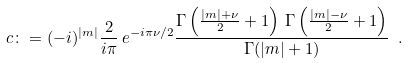Convert formula to latex. <formula><loc_0><loc_0><loc_500><loc_500>c \colon = ( - i ) ^ { | m | } \frac { 2 } { i \pi } \, e ^ { - i \pi \nu / 2 } \frac { \Gamma \left ( \frac { | m | + \nu } { 2 } + 1 \right ) \, \Gamma \left ( \frac { | m | - \nu } { 2 } + 1 \right ) } { \Gamma ( | m | + 1 ) } \ .</formula> 